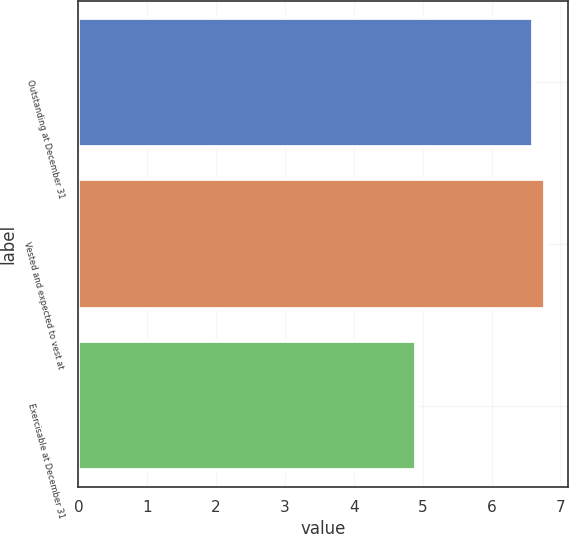Convert chart. <chart><loc_0><loc_0><loc_500><loc_500><bar_chart><fcel>Outstanding at December 31<fcel>Vested and expected to vest at<fcel>Exercisable at December 31<nl><fcel>6.6<fcel>6.77<fcel>4.9<nl></chart> 